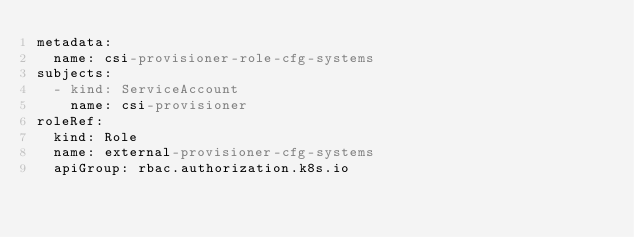<code> <loc_0><loc_0><loc_500><loc_500><_YAML_>metadata:
  name: csi-provisioner-role-cfg-systems
subjects:
  - kind: ServiceAccount
    name: csi-provisioner
roleRef:
  kind: Role
  name: external-provisioner-cfg-systems
  apiGroup: rbac.authorization.k8s.io
</code> 